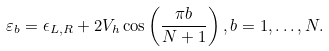<formula> <loc_0><loc_0><loc_500><loc_500>& \varepsilon _ { b } = \epsilon _ { L , R } + 2 V _ { h } \cos \left ( \frac { \pi b } { N + 1 } \right ) , b = 1 , \dots , N .</formula> 